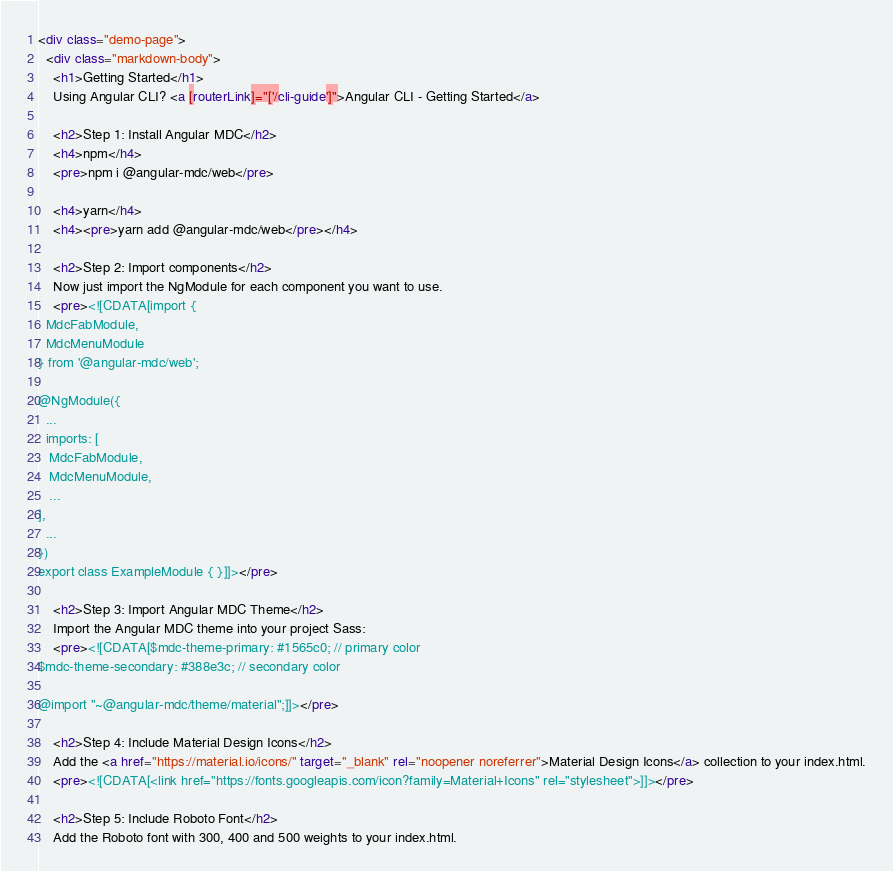Convert code to text. <code><loc_0><loc_0><loc_500><loc_500><_HTML_><div class="demo-page">
  <div class="markdown-body">
    <h1>Getting Started</h1>
    Using Angular CLI? <a [routerLink]="['/cli-guide']">Angular CLI - Getting Started</a>

    <h2>Step 1: Install Angular MDC</h2>
    <h4>npm</h4>
    <pre>npm i @angular-mdc/web</pre>

    <h4>yarn</h4>
    <h4><pre>yarn add @angular-mdc/web</pre></h4>

    <h2>Step 2: Import components</h2>
    Now just import the NgModule for each component you want to use.
    <pre><![CDATA[import {
  MdcFabModule,
  MdcMenuModule
} from '@angular-mdc/web';

@NgModule({
  ...
  imports: [
   MdcFabModule,
   MdcMenuModule,
   ...
],
  ...
})
export class ExampleModule { }]]></pre>

    <h2>Step 3: Import Angular MDC Theme</h2>
    Import the Angular MDC theme into your project Sass:
    <pre><![CDATA[$mdc-theme-primary: #1565c0; // primary color
$mdc-theme-secondary: #388e3c; // secondary color

@import "~@angular-mdc/theme/material";]]></pre>

    <h2>Step 4: Include Material Design Icons</h2>
    Add the <a href="https://material.io/icons/" target="_blank" rel="noopener noreferrer">Material Design Icons</a> collection to your index.html.
    <pre><![CDATA[<link href="https://fonts.googleapis.com/icon?family=Material+Icons" rel="stylesheet">]]></pre>

    <h2>Step 5: Include Roboto Font</h2>
    Add the Roboto font with 300, 400 and 500 weights to your index.html.
</code> 